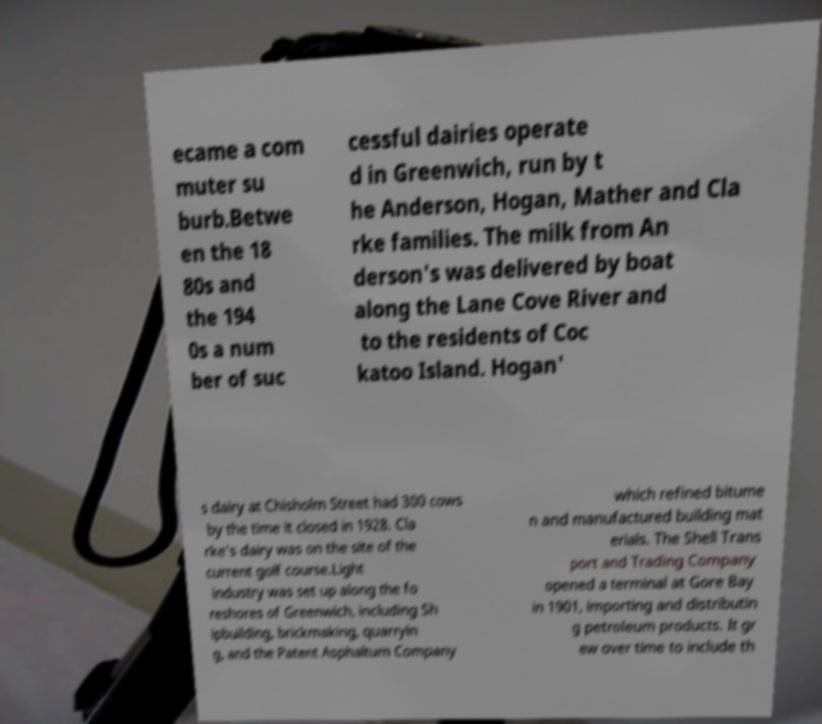For documentation purposes, I need the text within this image transcribed. Could you provide that? ecame a com muter su burb.Betwe en the 18 80s and the 194 0s a num ber of suc cessful dairies operate d in Greenwich, run by t he Anderson, Hogan, Mather and Cla rke families. The milk from An derson's was delivered by boat along the Lane Cove River and to the residents of Coc katoo Island. Hogan' s dairy at Chisholm Street had 300 cows by the time it closed in 1928. Cla rke's dairy was on the site of the current golf course.Light industry was set up along the fo reshores of Greenwich, including Sh ipbuilding, brickmaking, quarryin g, and the Patent Asphaltum Company which refined bitume n and manufactured building mat erials. The Shell Trans port and Trading Company opened a terminal at Gore Bay in 1901, importing and distributin g petroleum products. It gr ew over time to include th 